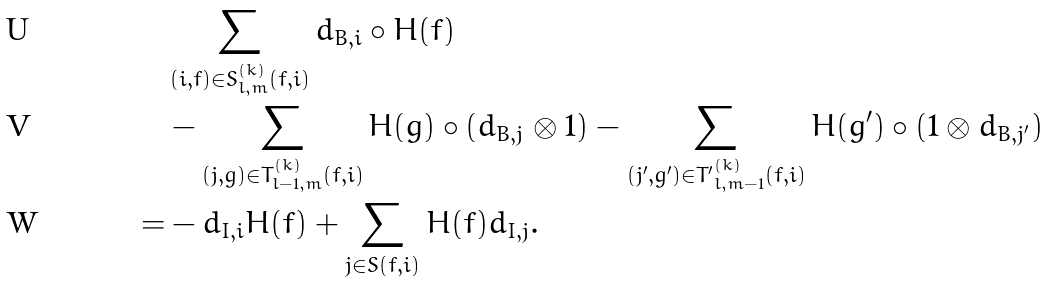Convert formula to latex. <formula><loc_0><loc_0><loc_500><loc_500>& \sum _ { ( i , f ) \in S _ { l , m } ^ { ( k ) } ( \bar { f } , i ) } d _ { B , i } \circ H ( f ) \\ & - \sum _ { ( j , g ) \in T _ { l - 1 , m } ^ { ( k ) } ( \bar { f } , i ) } H ( g ) \circ ( d _ { B , j } \otimes 1 ) - \sum _ { ( j ^ { \prime } , g ^ { \prime } ) \in { T ^ { \prime } } _ { l , m - 1 } ^ { ( k ) } ( \bar { f } , i ) } H ( g ^ { \prime } ) \circ ( 1 \otimes d _ { B , j ^ { \prime } } ) \\ = & - d _ { I , i } H ( \bar { f } ) + \sum _ { j \in S ( \bar { f } , i ) } H ( \bar { f } ) d _ { I , j } .</formula> 